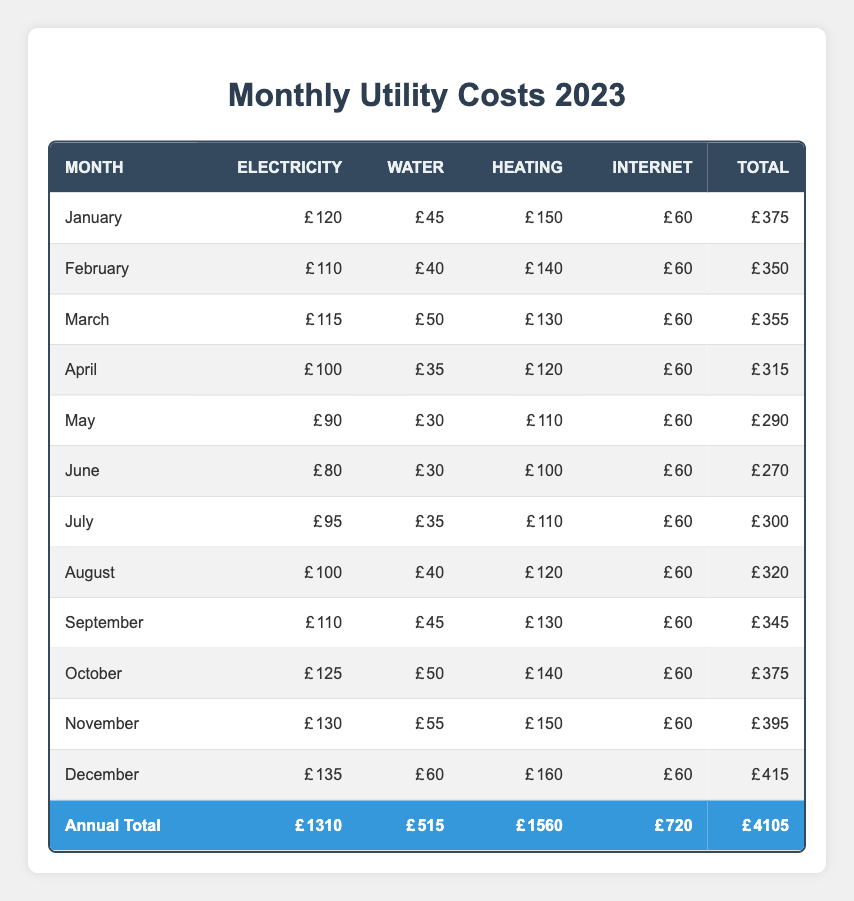What is the total utility cost for July? According to the table, the total utility cost for July is specified in the total column for that month. The value is 300.
Answer: 300 What was the electricity cost in December? The table lists the electricity cost for December under the electricity column. The value is 135.
Answer: 135 Which month had the highest total utility cost? To determine the month with the highest total utility cost, we look for the maximum value in the total column. December has the highest total, which is 415.
Answer: December Is the total utility cost for November greater than 400? The total utility cost for November is listed as 395 in the table. Since 395 is not greater than 400, the answer is no.
Answer: No What was the difference between the highest and lowest electricity costs? The highest electricity cost is in December, which is 135, and the lowest is in June, which is 80. The difference is 135 - 80 = 55.
Answer: 55 Which month experienced a total cost between 290 and 320? The total costs that fall between 290 and 320 in the table are for May (290), July (300), and August (320). Thus, there are three months: May, July, and August.
Answer: May, July, August What is the total spend on heating for the months of January to March? The heating costs for January, February, and March are 150, 140, and 130 respectively. To find the total, we add them: 150 + 140 + 130 = 420.
Answer: 420 Was there a month where total costs were lower than 300? The table shows that there are months below 300, specifically June (270), May (290), and April (315). Since June and May both have costs below 300, the answer is yes.
Answer: Yes 